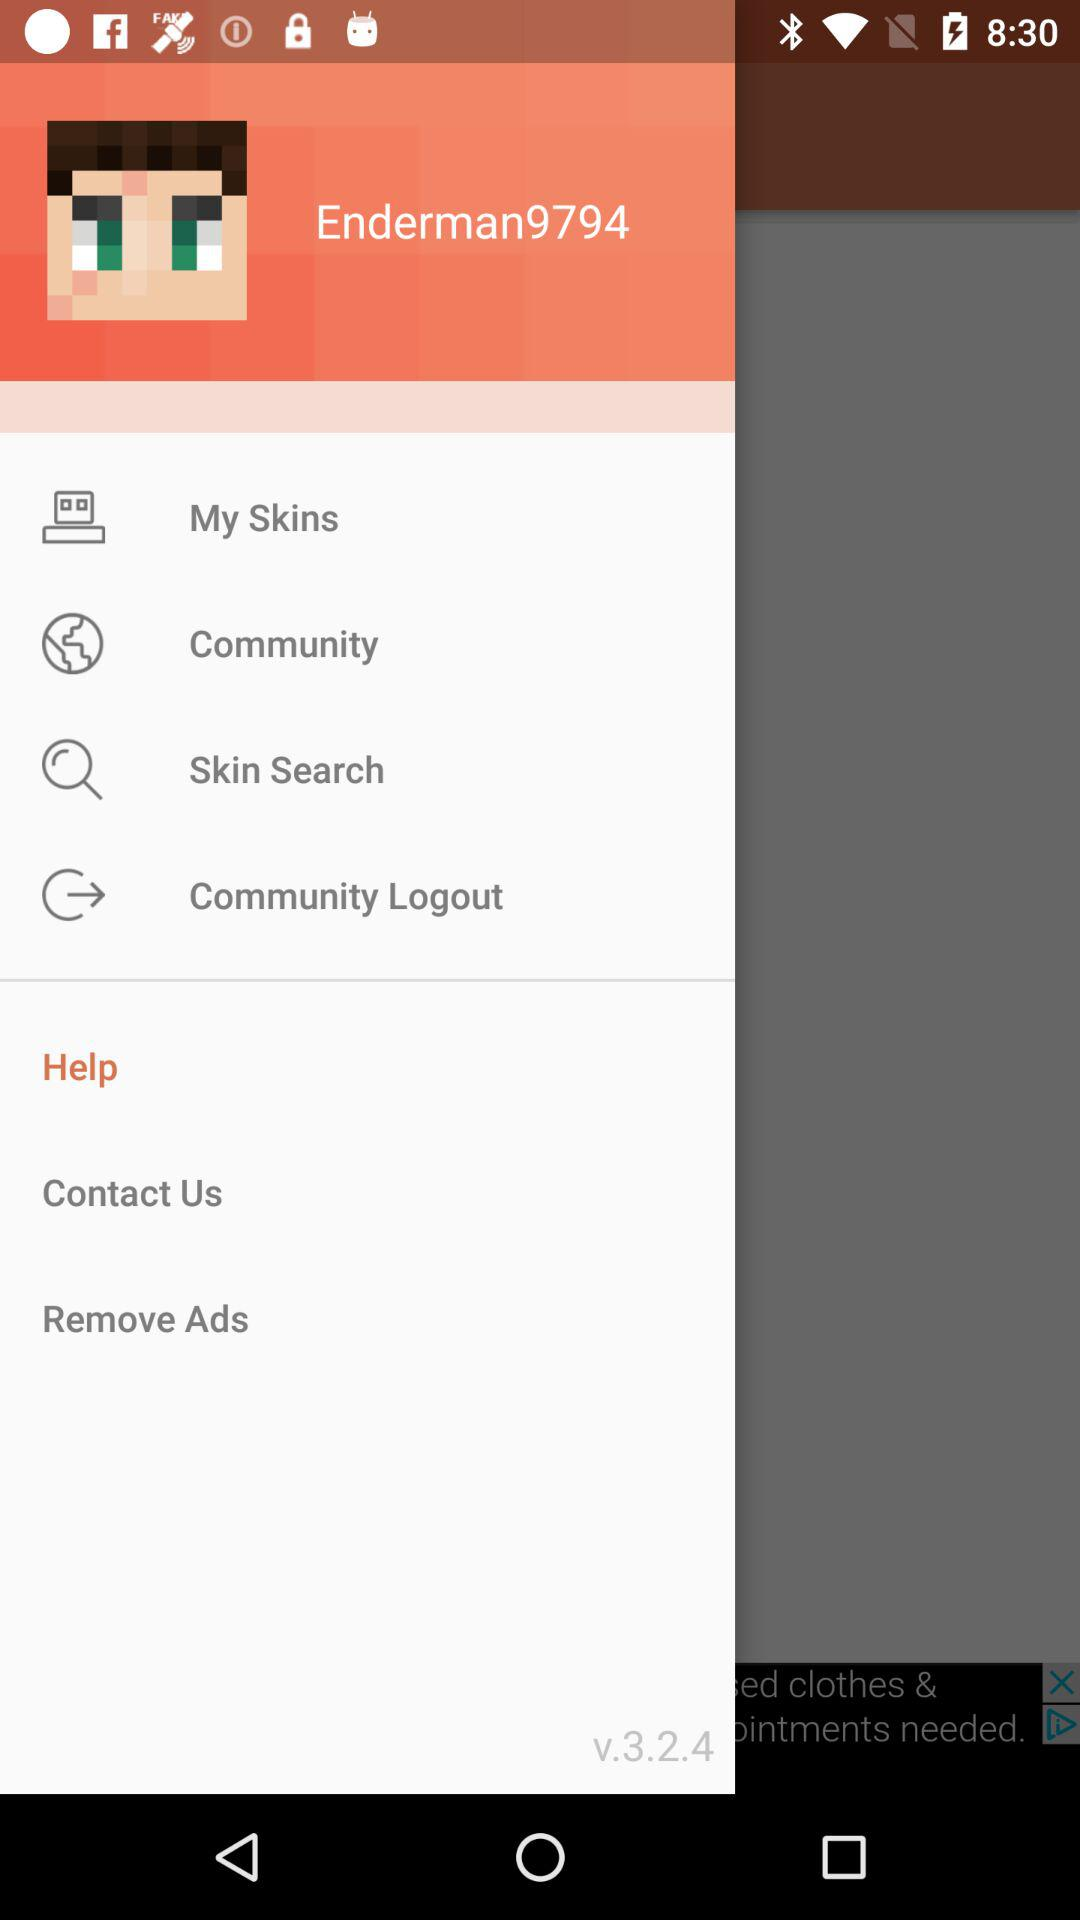What is the username? The username is "Enderman9794". 